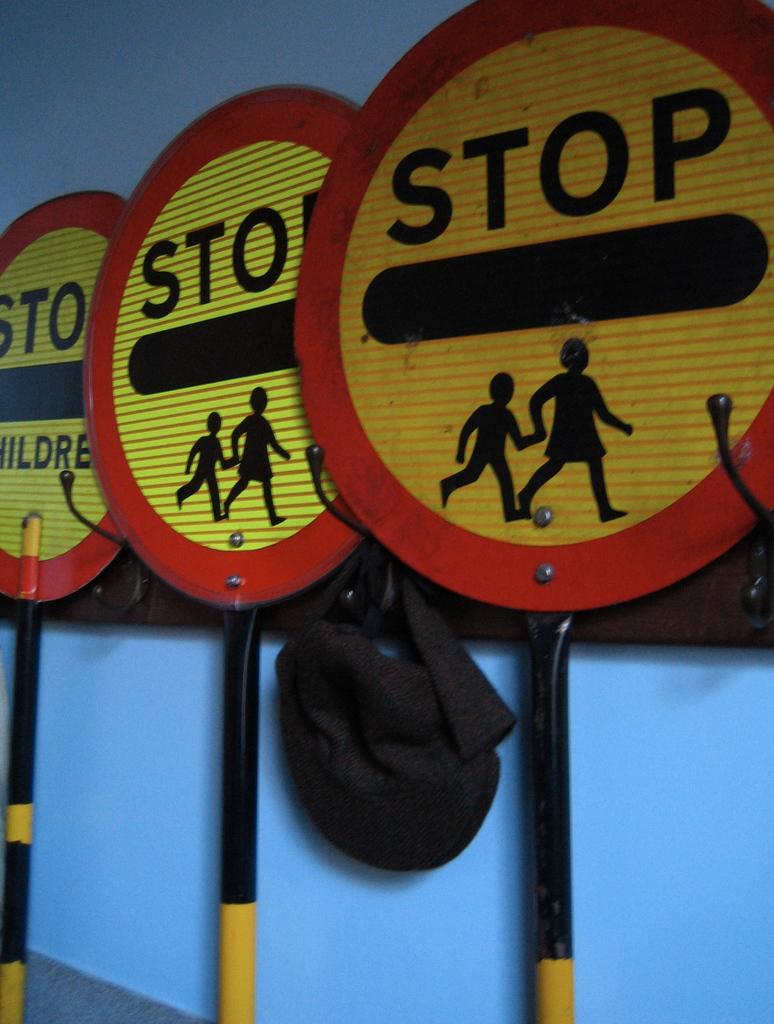What should you do if you see this sign?
Offer a very short reply. Stop. What does the sign say?
Your response must be concise. Stop. 